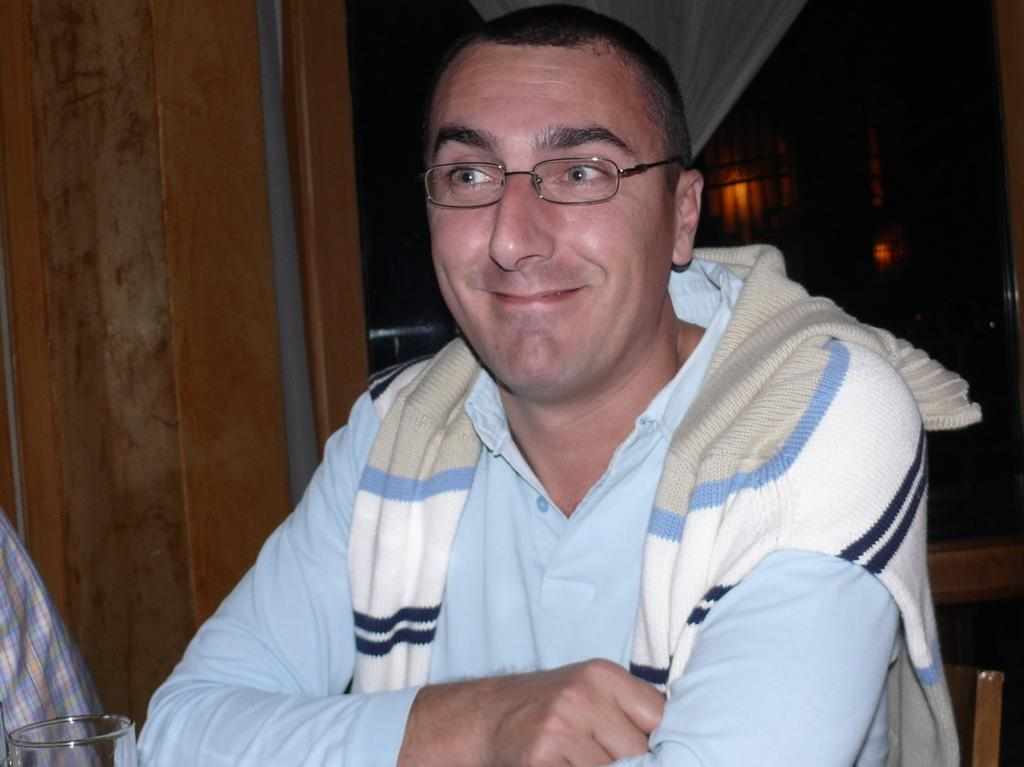What can be seen on the person's face in the image? There is a person with eyeglasses in the image. What object is visible near the person? There is a glass in the image. What type of material is used for the wall in the image? There is a wooden wall in the image. What type of window treatment is present in the image? There is a curtain in the image. What can be seen in the background of the image? There are lights in the background of the image. Can you tell me how many roots are visible in the image? There are no roots visible in the image. What type of animal can be seen interacting with the person in the image? There is no animal present in the image; it only features a person with eyeglasses, a glass, a wooden wall, a curtain, and lights in the background. 